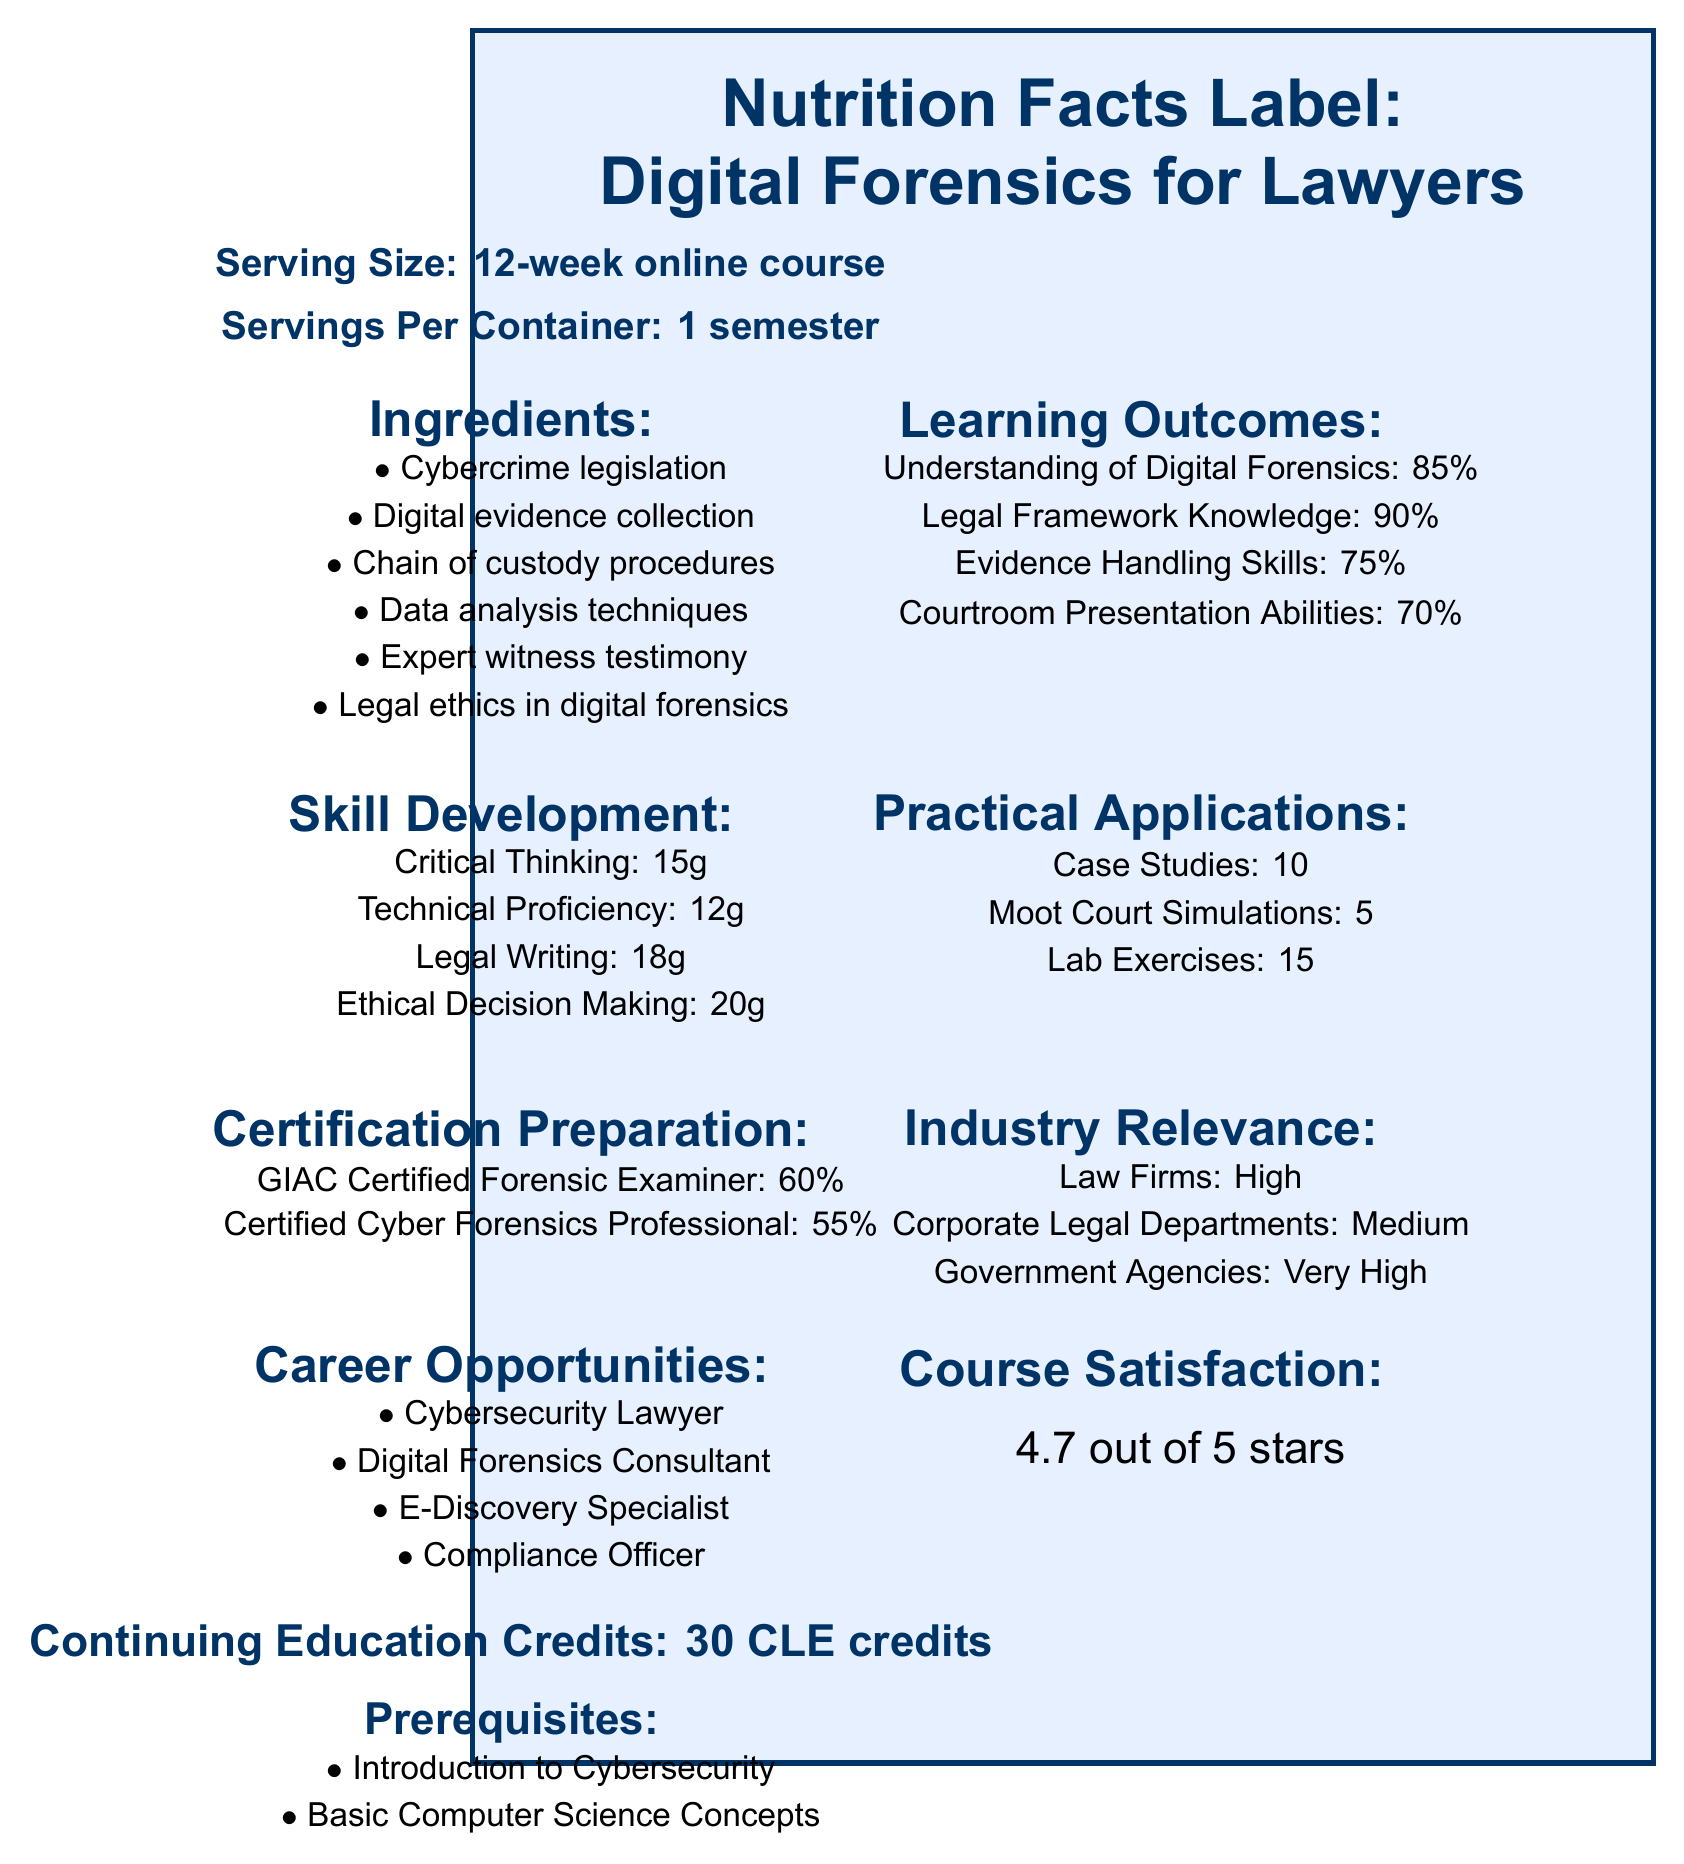what is the course title? The course title is explicitly stated at the top of the document.
Answer: Digital Forensics for Lawyers what is the serving size for this course? The serving size is specified as a 12-week online course in the document.
Answer: 12-week online course what are the two prerequisites for this course? The prerequisites are listed under the "Prerequisites" section.
Answer: Introduction to Cybersecurity, Basic Computer Science Concepts what percentage of the course assessment is based on practical labs? The "Assessment Methods" section specifies that practical labs account for 30% of the assessment.
Answer: 30% how many textbooks are listed in the course materials? The document lists two textbooks under "Course Materials."
Answer: 2 what is the industry relevance for government agencies? A. Low B. Medium C. High D. Very High The "Industry Relevance" section states that the relevance for government agencies is "Very High."
Answer: D which skill has the most development grams in the course? A. Critical Thinking B. Technical Proficiency C. Legal Writing D. Ethical Decision Making Ethical Decision Making has the most with 20g.
Answer: D how many career opportunities are listed in the document? A. 2 B. 3 C. 4 D. 5 There are four career opportunities listed: Cybersecurity Lawyer, Digital Forensics Consultant, E-Discovery Specialist, Compliance Officer.
Answer: C are there any guest lectures from an FBI Cyber Division Agent? The document mentions a guest lecture by an FBI Cyber Division Agent for 2 hours.
Answer: Yes what is the main idea of this document? The document is structured like a nutrition facts label to give a detailed outline of what the course entails and what students can expect to learn and achieve.
Answer: The document provides a comprehensive overview of the "Digital Forensics for Lawyers" course, including details about course length, skills developed, learning outcomes, practical applications, industry relevance, and assessment methods. how much is the course satisfaction rating? The course satisfaction rating is clearly stated as 4.7 out of 5 stars.
Answer: 4.7 out of 5 stars what types of certifications does the course prepare students for and what are their respective percentages? The "Certification Preparation" section states that the course prepares students to a 60% extent for GIAC Certified Forensic Examiner and 55% for Certified Cyber Forensics Professional.
Answer: GIAC Certified Forensic Examiner (60%), Certified Cyber Forensics Professional (55%) what type of software tools are included in the course materials? The document lists these software tools under the "Course Materials" section.
Answer: EnCase Forensic, Cellebrite UFED, Magnet AXIOM how many case studies are included as practical applications? The "Practical Applications" section lists 10 case studies.
Answer: 10 which guest lecture is the longest? The document shows that the guest lecture by a Digital Forensics Expert Witness is the longest at 3 hours.
Answer: Digital Forensics Expert Witness (3 hours) what prerequisites are needed for this course? The document lists "Introduction to Cybersecurity" and "Basic Computer Science Concepts" as prerequisites, but it doesn't specify the depth or specific topics these prerequisites cover.
Answer: Not enough information 